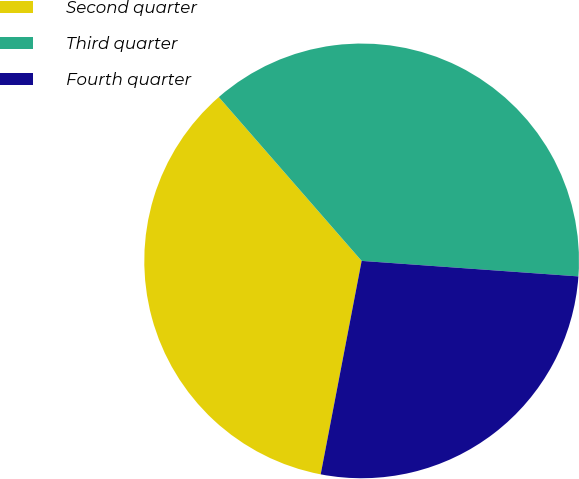Convert chart. <chart><loc_0><loc_0><loc_500><loc_500><pie_chart><fcel>Second quarter<fcel>Third quarter<fcel>Fourth quarter<nl><fcel>35.57%<fcel>37.55%<fcel>26.88%<nl></chart> 